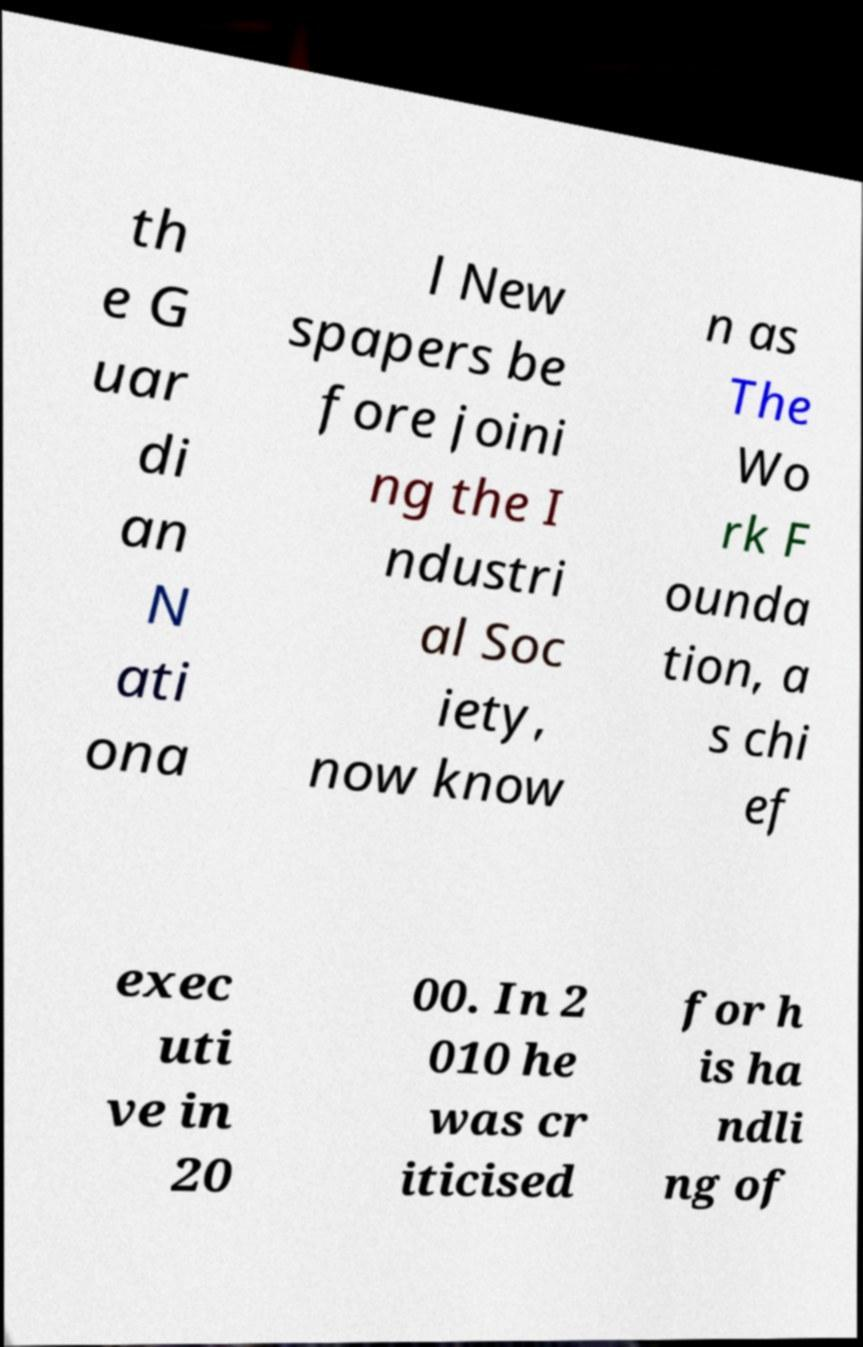Please read and relay the text visible in this image. What does it say? th e G uar di an N ati ona l New spapers be fore joini ng the I ndustri al Soc iety, now know n as The Wo rk F ounda tion, a s chi ef exec uti ve in 20 00. In 2 010 he was cr iticised for h is ha ndli ng of 